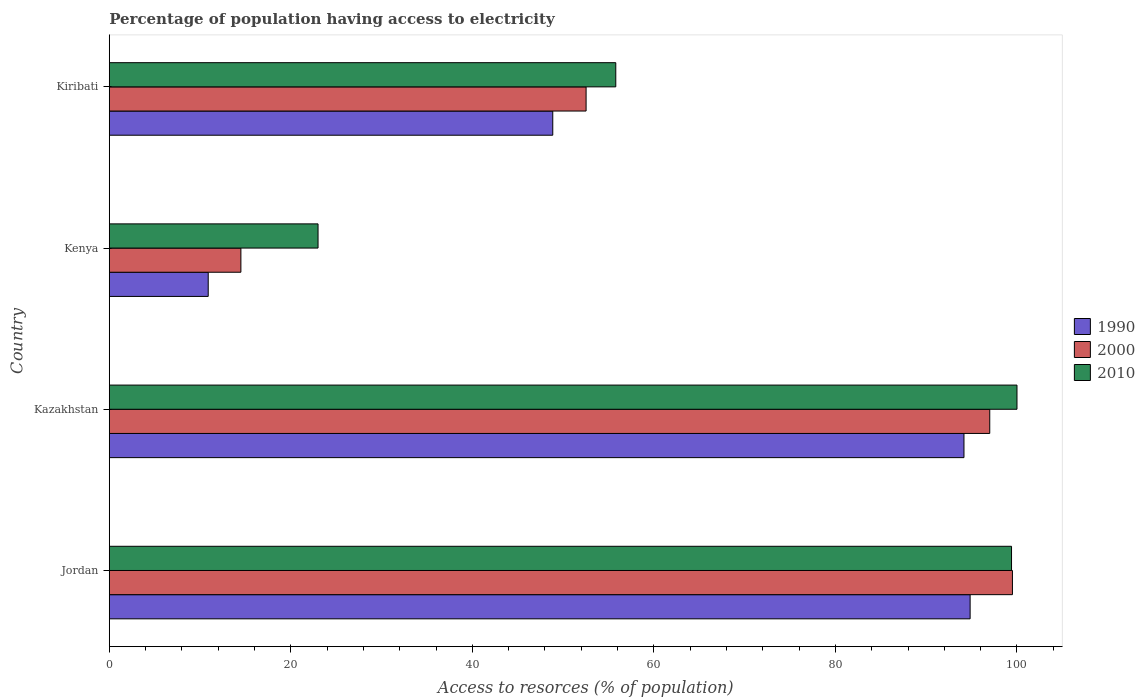How many different coloured bars are there?
Your response must be concise. 3. How many groups of bars are there?
Your answer should be very brief. 4. Are the number of bars on each tick of the Y-axis equal?
Offer a very short reply. Yes. What is the label of the 4th group of bars from the top?
Your answer should be very brief. Jordan. What is the percentage of population having access to electricity in 2010 in Jordan?
Offer a very short reply. 99.4. Across all countries, what is the maximum percentage of population having access to electricity in 2000?
Make the answer very short. 99.5. In which country was the percentage of population having access to electricity in 1990 maximum?
Provide a succinct answer. Jordan. In which country was the percentage of population having access to electricity in 2010 minimum?
Your response must be concise. Kenya. What is the total percentage of population having access to electricity in 1990 in the graph?
Your response must be concise. 248.76. What is the difference between the percentage of population having access to electricity in 2010 in Kenya and that in Kiribati?
Keep it short and to the point. -32.8. What is the difference between the percentage of population having access to electricity in 2000 in Kazakhstan and the percentage of population having access to electricity in 1990 in Kenya?
Your answer should be compact. 86.1. What is the average percentage of population having access to electricity in 1990 per country?
Give a very brief answer. 62.19. What is the difference between the percentage of population having access to electricity in 1990 and percentage of population having access to electricity in 2010 in Jordan?
Make the answer very short. -4.56. In how many countries, is the percentage of population having access to electricity in 2000 greater than 68 %?
Your answer should be very brief. 2. What is the ratio of the percentage of population having access to electricity in 1990 in Jordan to that in Kiribati?
Give a very brief answer. 1.94. Is the difference between the percentage of population having access to electricity in 1990 in Kazakhstan and Kenya greater than the difference between the percentage of population having access to electricity in 2010 in Kazakhstan and Kenya?
Your answer should be compact. Yes. What is the difference between the highest and the second highest percentage of population having access to electricity in 2010?
Ensure brevity in your answer.  0.6. What is the difference between the highest and the lowest percentage of population having access to electricity in 1990?
Your answer should be compact. 83.94. What does the 1st bar from the top in Kiribati represents?
Provide a succinct answer. 2010. How many bars are there?
Offer a terse response. 12. What is the difference between two consecutive major ticks on the X-axis?
Give a very brief answer. 20. Does the graph contain any zero values?
Your answer should be very brief. No. How many legend labels are there?
Give a very brief answer. 3. How are the legend labels stacked?
Keep it short and to the point. Vertical. What is the title of the graph?
Your answer should be compact. Percentage of population having access to electricity. What is the label or title of the X-axis?
Give a very brief answer. Access to resorces (% of population). What is the Access to resorces (% of population) in 1990 in Jordan?
Ensure brevity in your answer.  94.84. What is the Access to resorces (% of population) of 2000 in Jordan?
Your answer should be very brief. 99.5. What is the Access to resorces (% of population) in 2010 in Jordan?
Offer a terse response. 99.4. What is the Access to resorces (% of population) in 1990 in Kazakhstan?
Give a very brief answer. 94.16. What is the Access to resorces (% of population) in 2000 in Kazakhstan?
Give a very brief answer. 97. What is the Access to resorces (% of population) in 2010 in Kenya?
Give a very brief answer. 23. What is the Access to resorces (% of population) of 1990 in Kiribati?
Your response must be concise. 48.86. What is the Access to resorces (% of population) of 2000 in Kiribati?
Provide a succinct answer. 52.53. What is the Access to resorces (% of population) in 2010 in Kiribati?
Your answer should be compact. 55.8. Across all countries, what is the maximum Access to resorces (% of population) of 1990?
Keep it short and to the point. 94.84. Across all countries, what is the maximum Access to resorces (% of population) in 2000?
Make the answer very short. 99.5. Across all countries, what is the maximum Access to resorces (% of population) in 2010?
Your answer should be compact. 100. Across all countries, what is the minimum Access to resorces (% of population) of 2000?
Keep it short and to the point. 14.5. What is the total Access to resorces (% of population) of 1990 in the graph?
Give a very brief answer. 248.76. What is the total Access to resorces (% of population) of 2000 in the graph?
Provide a short and direct response. 263.53. What is the total Access to resorces (% of population) in 2010 in the graph?
Make the answer very short. 278.2. What is the difference between the Access to resorces (% of population) in 1990 in Jordan and that in Kazakhstan?
Offer a terse response. 0.68. What is the difference between the Access to resorces (% of population) in 2010 in Jordan and that in Kazakhstan?
Provide a short and direct response. -0.6. What is the difference between the Access to resorces (% of population) of 1990 in Jordan and that in Kenya?
Give a very brief answer. 83.94. What is the difference between the Access to resorces (% of population) of 2010 in Jordan and that in Kenya?
Provide a succinct answer. 76.4. What is the difference between the Access to resorces (% of population) of 1990 in Jordan and that in Kiribati?
Offer a terse response. 45.98. What is the difference between the Access to resorces (% of population) in 2000 in Jordan and that in Kiribati?
Your answer should be very brief. 46.97. What is the difference between the Access to resorces (% of population) in 2010 in Jordan and that in Kiribati?
Provide a short and direct response. 43.6. What is the difference between the Access to resorces (% of population) in 1990 in Kazakhstan and that in Kenya?
Give a very brief answer. 83.26. What is the difference between the Access to resorces (% of population) in 2000 in Kazakhstan and that in Kenya?
Provide a succinct answer. 82.5. What is the difference between the Access to resorces (% of population) in 1990 in Kazakhstan and that in Kiribati?
Offer a very short reply. 45.3. What is the difference between the Access to resorces (% of population) of 2000 in Kazakhstan and that in Kiribati?
Offer a very short reply. 44.47. What is the difference between the Access to resorces (% of population) in 2010 in Kazakhstan and that in Kiribati?
Provide a succinct answer. 44.2. What is the difference between the Access to resorces (% of population) in 1990 in Kenya and that in Kiribati?
Your response must be concise. -37.96. What is the difference between the Access to resorces (% of population) of 2000 in Kenya and that in Kiribati?
Keep it short and to the point. -38.03. What is the difference between the Access to resorces (% of population) in 2010 in Kenya and that in Kiribati?
Offer a terse response. -32.8. What is the difference between the Access to resorces (% of population) in 1990 in Jordan and the Access to resorces (% of population) in 2000 in Kazakhstan?
Offer a very short reply. -2.16. What is the difference between the Access to resorces (% of population) in 1990 in Jordan and the Access to resorces (% of population) in 2010 in Kazakhstan?
Provide a succinct answer. -5.16. What is the difference between the Access to resorces (% of population) in 1990 in Jordan and the Access to resorces (% of population) in 2000 in Kenya?
Your response must be concise. 80.34. What is the difference between the Access to resorces (% of population) in 1990 in Jordan and the Access to resorces (% of population) in 2010 in Kenya?
Your answer should be very brief. 71.84. What is the difference between the Access to resorces (% of population) in 2000 in Jordan and the Access to resorces (% of population) in 2010 in Kenya?
Ensure brevity in your answer.  76.5. What is the difference between the Access to resorces (% of population) of 1990 in Jordan and the Access to resorces (% of population) of 2000 in Kiribati?
Make the answer very short. 42.31. What is the difference between the Access to resorces (% of population) of 1990 in Jordan and the Access to resorces (% of population) of 2010 in Kiribati?
Provide a short and direct response. 39.04. What is the difference between the Access to resorces (% of population) of 2000 in Jordan and the Access to resorces (% of population) of 2010 in Kiribati?
Provide a succinct answer. 43.7. What is the difference between the Access to resorces (% of population) of 1990 in Kazakhstan and the Access to resorces (% of population) of 2000 in Kenya?
Ensure brevity in your answer.  79.66. What is the difference between the Access to resorces (% of population) in 1990 in Kazakhstan and the Access to resorces (% of population) in 2010 in Kenya?
Provide a succinct answer. 71.16. What is the difference between the Access to resorces (% of population) in 2000 in Kazakhstan and the Access to resorces (% of population) in 2010 in Kenya?
Ensure brevity in your answer.  74. What is the difference between the Access to resorces (% of population) of 1990 in Kazakhstan and the Access to resorces (% of population) of 2000 in Kiribati?
Provide a short and direct response. 41.63. What is the difference between the Access to resorces (% of population) of 1990 in Kazakhstan and the Access to resorces (% of population) of 2010 in Kiribati?
Provide a succinct answer. 38.36. What is the difference between the Access to resorces (% of population) in 2000 in Kazakhstan and the Access to resorces (% of population) in 2010 in Kiribati?
Provide a short and direct response. 41.2. What is the difference between the Access to resorces (% of population) in 1990 in Kenya and the Access to resorces (% of population) in 2000 in Kiribati?
Provide a succinct answer. -41.63. What is the difference between the Access to resorces (% of population) in 1990 in Kenya and the Access to resorces (% of population) in 2010 in Kiribati?
Keep it short and to the point. -44.9. What is the difference between the Access to resorces (% of population) in 2000 in Kenya and the Access to resorces (% of population) in 2010 in Kiribati?
Make the answer very short. -41.3. What is the average Access to resorces (% of population) in 1990 per country?
Your response must be concise. 62.19. What is the average Access to resorces (% of population) of 2000 per country?
Ensure brevity in your answer.  65.88. What is the average Access to resorces (% of population) of 2010 per country?
Your answer should be very brief. 69.55. What is the difference between the Access to resorces (% of population) in 1990 and Access to resorces (% of population) in 2000 in Jordan?
Offer a very short reply. -4.66. What is the difference between the Access to resorces (% of population) of 1990 and Access to resorces (% of population) of 2010 in Jordan?
Provide a short and direct response. -4.56. What is the difference between the Access to resorces (% of population) of 2000 and Access to resorces (% of population) of 2010 in Jordan?
Your response must be concise. 0.1. What is the difference between the Access to resorces (% of population) in 1990 and Access to resorces (% of population) in 2000 in Kazakhstan?
Keep it short and to the point. -2.84. What is the difference between the Access to resorces (% of population) of 1990 and Access to resorces (% of population) of 2010 in Kazakhstan?
Ensure brevity in your answer.  -5.84. What is the difference between the Access to resorces (% of population) of 2000 and Access to resorces (% of population) of 2010 in Kazakhstan?
Your answer should be very brief. -3. What is the difference between the Access to resorces (% of population) of 1990 and Access to resorces (% of population) of 2000 in Kiribati?
Provide a short and direct response. -3.67. What is the difference between the Access to resorces (% of population) in 1990 and Access to resorces (% of population) in 2010 in Kiribati?
Give a very brief answer. -6.94. What is the difference between the Access to resorces (% of population) in 2000 and Access to resorces (% of population) in 2010 in Kiribati?
Provide a short and direct response. -3.27. What is the ratio of the Access to resorces (% of population) of 2000 in Jordan to that in Kazakhstan?
Provide a short and direct response. 1.03. What is the ratio of the Access to resorces (% of population) in 2010 in Jordan to that in Kazakhstan?
Keep it short and to the point. 0.99. What is the ratio of the Access to resorces (% of population) in 1990 in Jordan to that in Kenya?
Offer a very short reply. 8.7. What is the ratio of the Access to resorces (% of population) of 2000 in Jordan to that in Kenya?
Your answer should be compact. 6.86. What is the ratio of the Access to resorces (% of population) in 2010 in Jordan to that in Kenya?
Provide a succinct answer. 4.32. What is the ratio of the Access to resorces (% of population) in 1990 in Jordan to that in Kiribati?
Your answer should be very brief. 1.94. What is the ratio of the Access to resorces (% of population) in 2000 in Jordan to that in Kiribati?
Provide a short and direct response. 1.89. What is the ratio of the Access to resorces (% of population) of 2010 in Jordan to that in Kiribati?
Ensure brevity in your answer.  1.78. What is the ratio of the Access to resorces (% of population) of 1990 in Kazakhstan to that in Kenya?
Make the answer very short. 8.64. What is the ratio of the Access to resorces (% of population) of 2000 in Kazakhstan to that in Kenya?
Keep it short and to the point. 6.69. What is the ratio of the Access to resorces (% of population) in 2010 in Kazakhstan to that in Kenya?
Offer a very short reply. 4.35. What is the ratio of the Access to resorces (% of population) in 1990 in Kazakhstan to that in Kiribati?
Offer a very short reply. 1.93. What is the ratio of the Access to resorces (% of population) in 2000 in Kazakhstan to that in Kiribati?
Ensure brevity in your answer.  1.85. What is the ratio of the Access to resorces (% of population) of 2010 in Kazakhstan to that in Kiribati?
Ensure brevity in your answer.  1.79. What is the ratio of the Access to resorces (% of population) of 1990 in Kenya to that in Kiribati?
Offer a very short reply. 0.22. What is the ratio of the Access to resorces (% of population) in 2000 in Kenya to that in Kiribati?
Ensure brevity in your answer.  0.28. What is the ratio of the Access to resorces (% of population) of 2010 in Kenya to that in Kiribati?
Keep it short and to the point. 0.41. What is the difference between the highest and the second highest Access to resorces (% of population) of 1990?
Provide a succinct answer. 0.68. What is the difference between the highest and the lowest Access to resorces (% of population) in 1990?
Keep it short and to the point. 83.94. What is the difference between the highest and the lowest Access to resorces (% of population) of 2000?
Your answer should be very brief. 85. What is the difference between the highest and the lowest Access to resorces (% of population) of 2010?
Your answer should be compact. 77. 